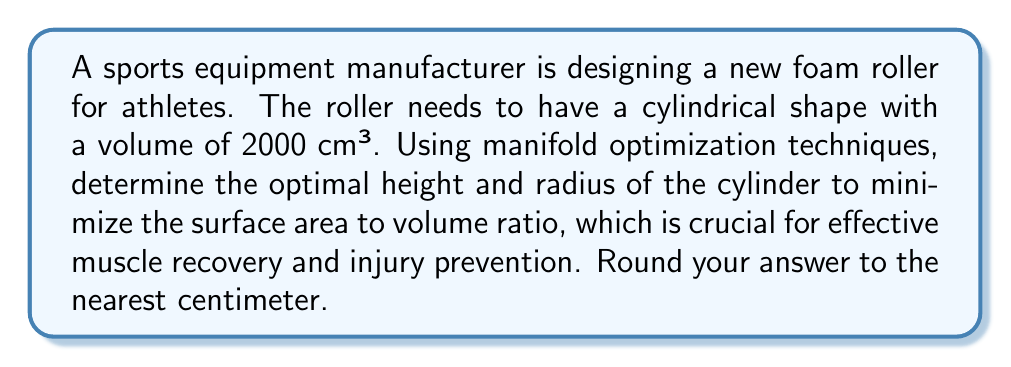Could you help me with this problem? To solve this problem, we'll use manifold optimization techniques to minimize the surface area to volume ratio of a cylinder.

1. Let's define our variables:
   $r$ = radius of the base
   $h$ = height of the cylinder
   $V$ = volume of the cylinder
   $SA$ = surface area of the cylinder

2. Given:
   $V = 2000$ cm³

3. Formulas:
   Volume of a cylinder: $V = \pi r^2 h$
   Surface area of a cylinder: $SA = 2\pi r^2 + 2\pi r h$

4. Our objective is to minimize the surface area to volume ratio:
   $\min \frac{SA}{V} = \frac{2\pi r^2 + 2\pi r h}{2000}$

5. We have the constraint: $\pi r^2 h = 2000$

6. Using the constraint, we can express $h$ in terms of $r$:
   $h = \frac{2000}{\pi r^2}$

7. Substituting this into our objective function:
   $\frac{SA}{V} = \frac{2\pi r^2 + 2\pi r (\frac{2000}{\pi r^2})}{2000}$
   $= \frac{2\pi r^2 + \frac{4000}{r}}{2000}$

8. To find the minimum, we differentiate with respect to $r$ and set it to zero:
   $\frac{d}{dr}(\frac{SA}{V}) = \frac{4\pi r - \frac{4000}{r^2}}{2000} = 0$

9. Solving this equation:
   $4\pi r = \frac{4000}{r^2}$
   $4\pi r^3 = 4000$
   $r^3 = \frac{1000}{\pi}$
   $r = \sqrt[3]{\frac{1000}{\pi}} \approx 6.20$ cm

10. Using the constraint equation to find $h$:
    $h = \frac{2000}{\pi r^2} \approx 16.54$ cm

11. Rounding to the nearest centimeter:
    $r \approx 6$ cm
    $h \approx 17$ cm

This solution represents the optimal dimensions for minimizing the surface area to volume ratio of the foam roller, which is important for effective muscle recovery and injury prevention in athletes.
Answer: The optimal dimensions for the foam roller are approximately 6 cm in radius and 17 cm in height. 